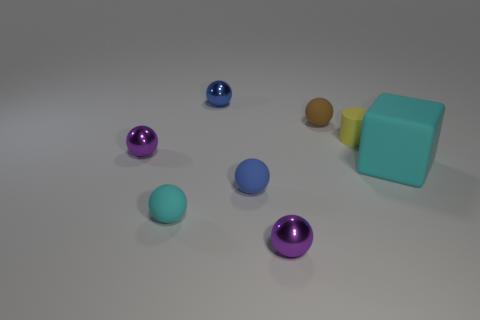Subtract 1 spheres. How many spheres are left? 5 Subtract all cyan spheres. How many spheres are left? 5 Subtract all brown spheres. How many spheres are left? 5 Add 1 big matte cylinders. How many objects exist? 9 Subtract all green spheres. Subtract all green blocks. How many spheres are left? 6 Subtract all spheres. How many objects are left? 2 Add 1 brown balls. How many brown balls are left? 2 Add 3 small yellow matte things. How many small yellow matte things exist? 4 Subtract 0 red cylinders. How many objects are left? 8 Subtract all cyan balls. Subtract all tiny blue rubber spheres. How many objects are left? 6 